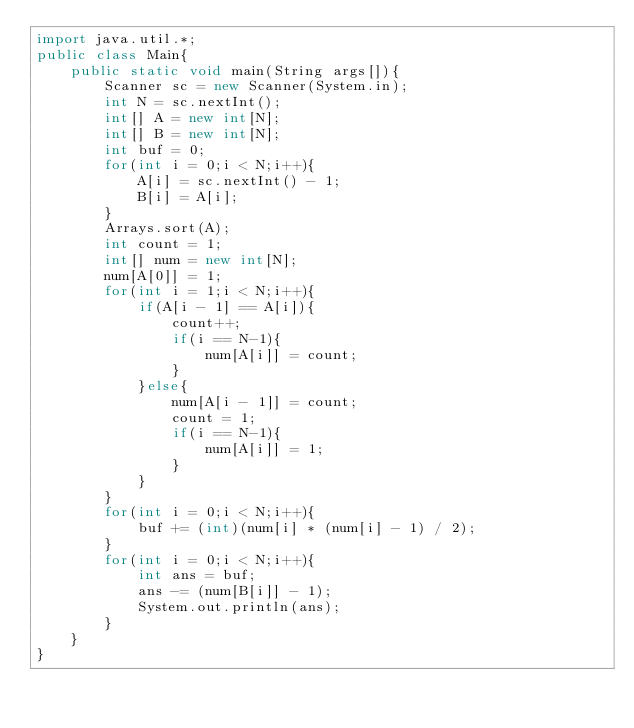Convert code to text. <code><loc_0><loc_0><loc_500><loc_500><_Java_>import java.util.*;
public class Main{
	public static void main(String args[]){
		Scanner sc = new Scanner(System.in);
		int N = sc.nextInt();
		int[] A = new int[N];
		int[] B = new int[N];
		int buf = 0;
		for(int i = 0;i < N;i++){
			A[i] = sc.nextInt() - 1;
			B[i] = A[i];
		}
		Arrays.sort(A);
		int count = 1;
		int[] num = new int[N];
		num[A[0]] = 1;
		for(int i = 1;i < N;i++){
			if(A[i - 1] == A[i]){
				count++;
				if(i == N-1){
					num[A[i]] = count;
				}
			}else{
				num[A[i - 1]] = count;
				count = 1;
				if(i == N-1){
					num[A[i]] = 1;
				}
			}
		}
		for(int i = 0;i < N;i++){
			buf += (int)(num[i] * (num[i] - 1) / 2);
		}
		for(int i = 0;i < N;i++){
			int ans = buf;
			ans -= (num[B[i]] - 1);
			System.out.println(ans);
		}
	}
}</code> 